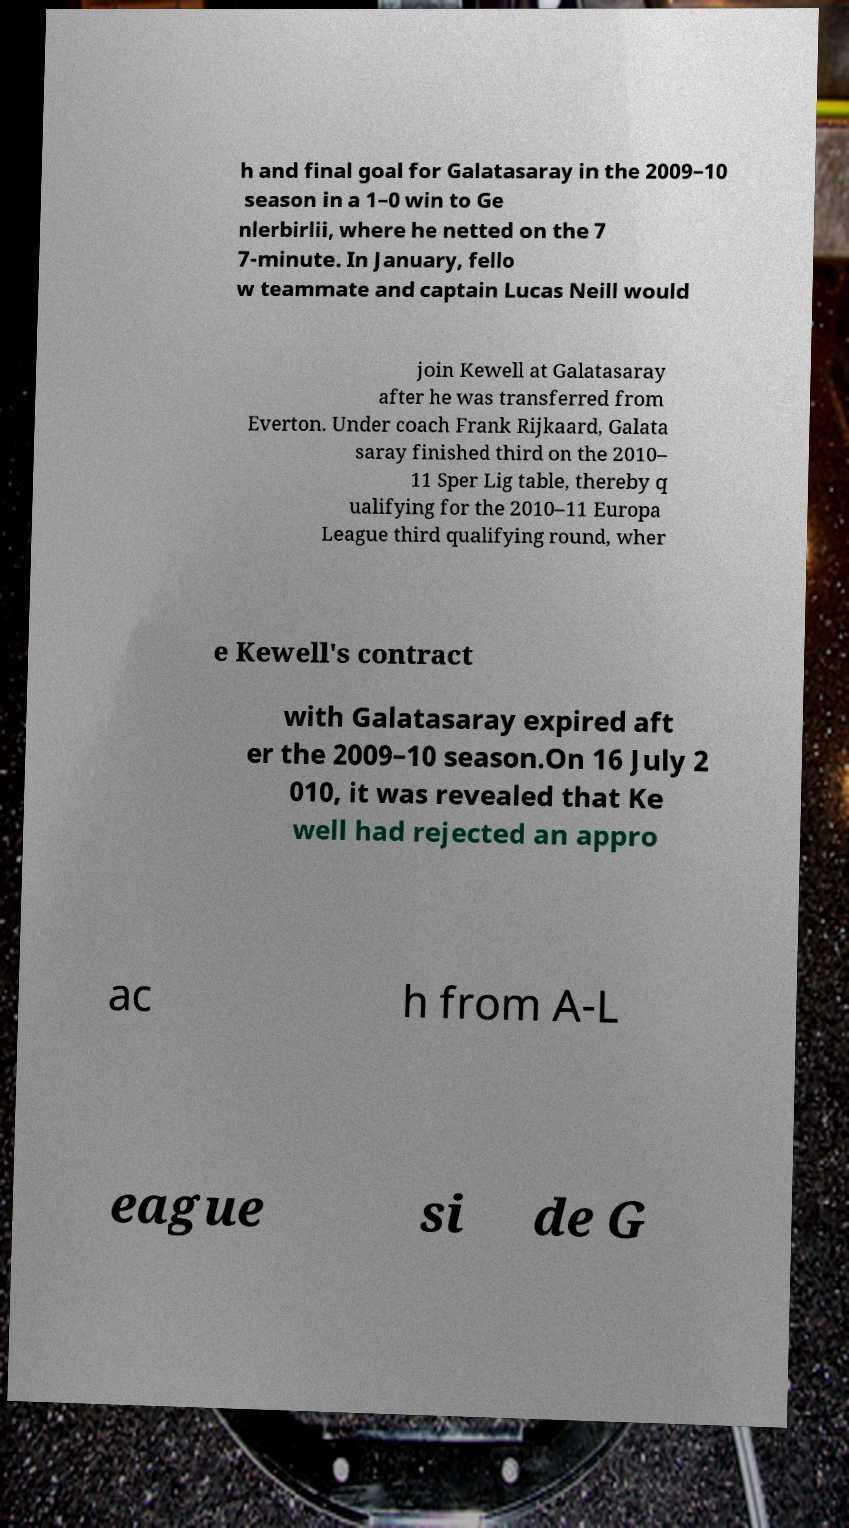I need the written content from this picture converted into text. Can you do that? h and final goal for Galatasaray in the 2009–10 season in a 1–0 win to Ge nlerbirlii, where he netted on the 7 7-minute. In January, fello w teammate and captain Lucas Neill would join Kewell at Galatasaray after he was transferred from Everton. Under coach Frank Rijkaard, Galata saray finished third on the 2010– 11 Sper Lig table, thereby q ualifying for the 2010–11 Europa League third qualifying round, wher e Kewell's contract with Galatasaray expired aft er the 2009–10 season.On 16 July 2 010, it was revealed that Ke well had rejected an appro ac h from A-L eague si de G 